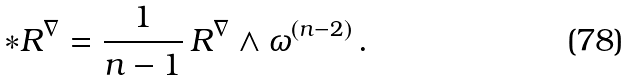Convert formula to latex. <formula><loc_0><loc_0><loc_500><loc_500>\ast R ^ { \nabla } = \frac { 1 } { n - 1 } \, R ^ { \nabla } \wedge \omega ^ { ( n - 2 ) } \, .</formula> 